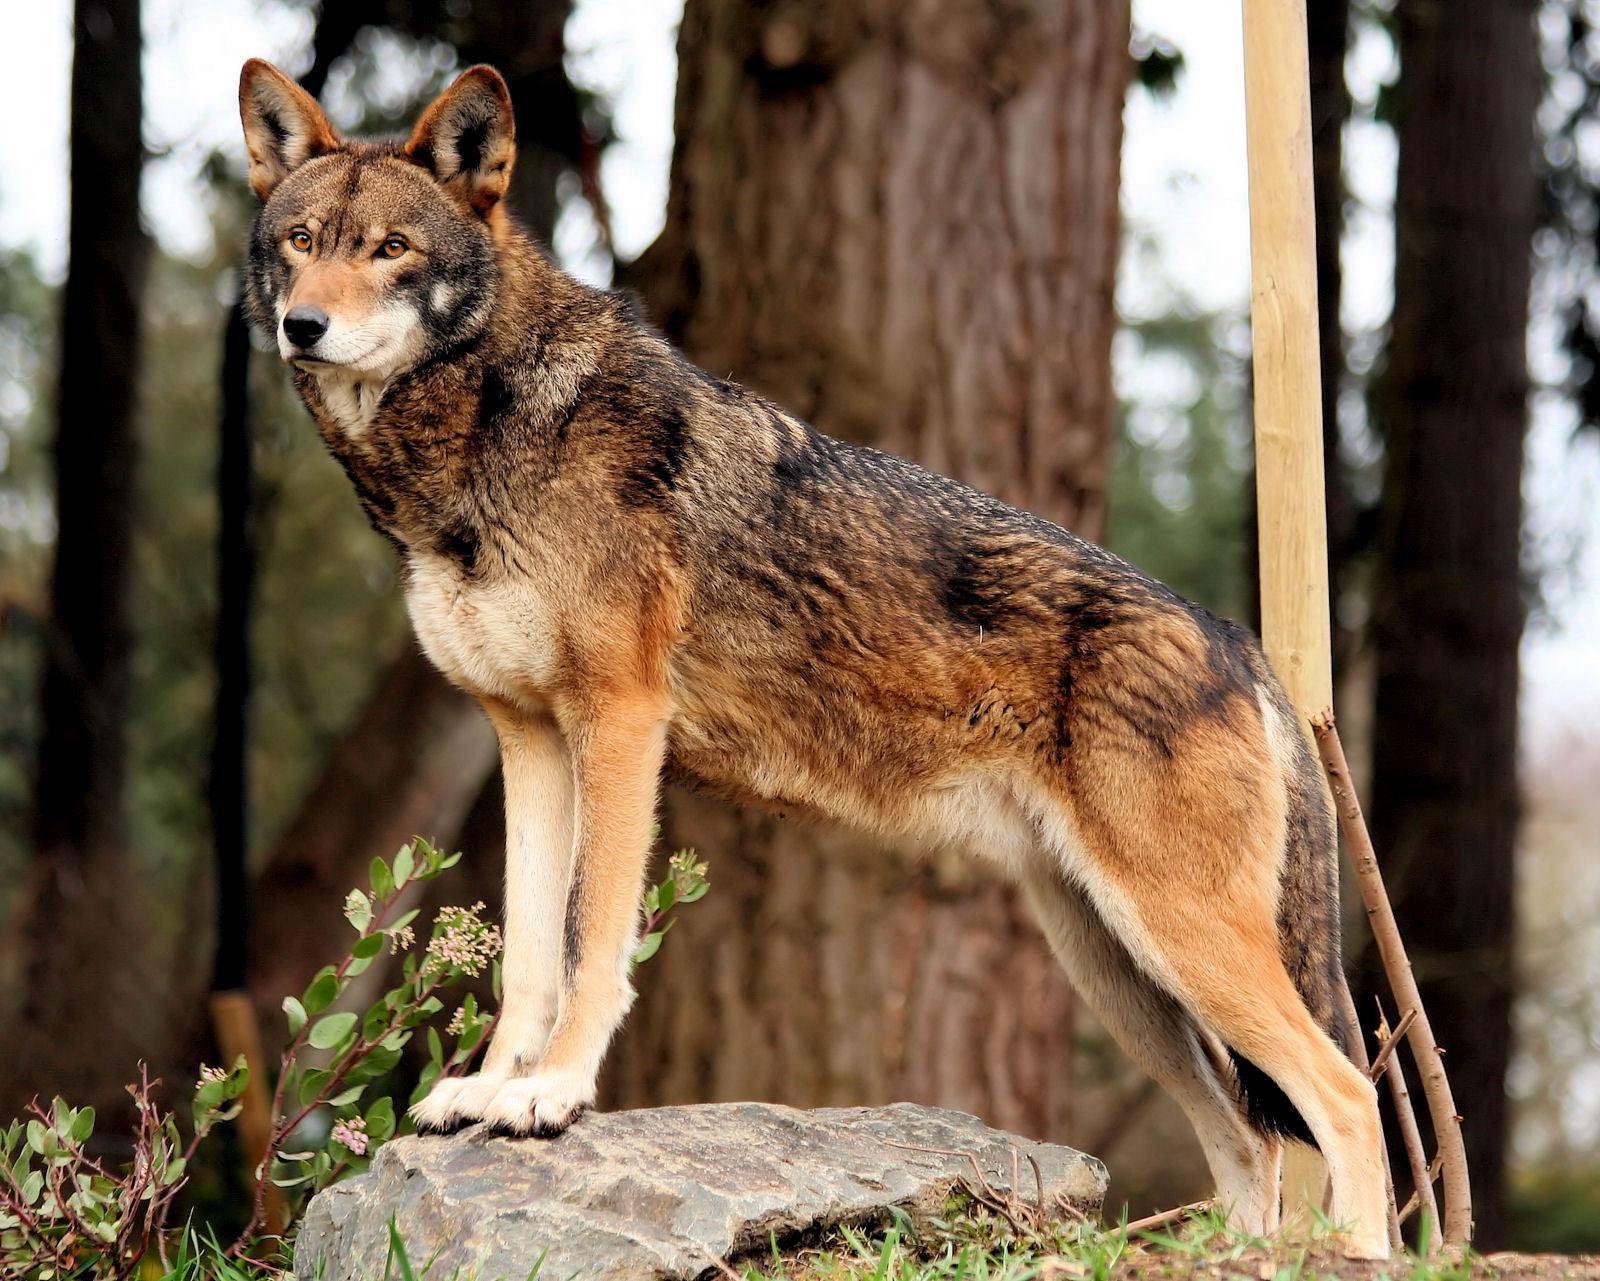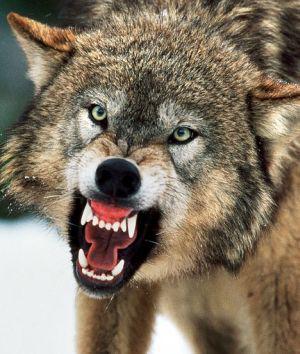The first image is the image on the left, the second image is the image on the right. For the images shown, is this caption "An image shows a wolf with a dusting of snow on its fur." true? Answer yes or no. No. The first image is the image on the left, the second image is the image on the right. Analyze the images presented: Is the assertion "The wild dog in one of the images is lying down." valid? Answer yes or no. No. 